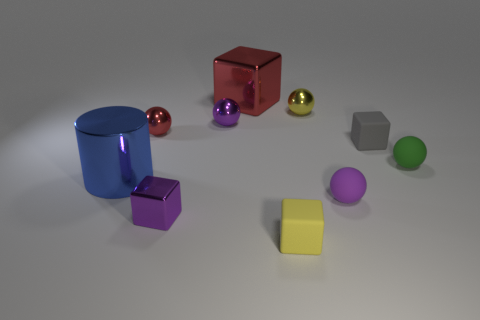Can you describe the shapes and colors of the objects in the image? Certainly! The image shows a collection of geometric shapes in various colors. There's a blue cylinder, a reflective red cube, two spheres - one gold, another pink, a silver hexahedron, a green sphere, a purple cube, and a flat yellow square. Each object has a smooth, lustrous surface. 